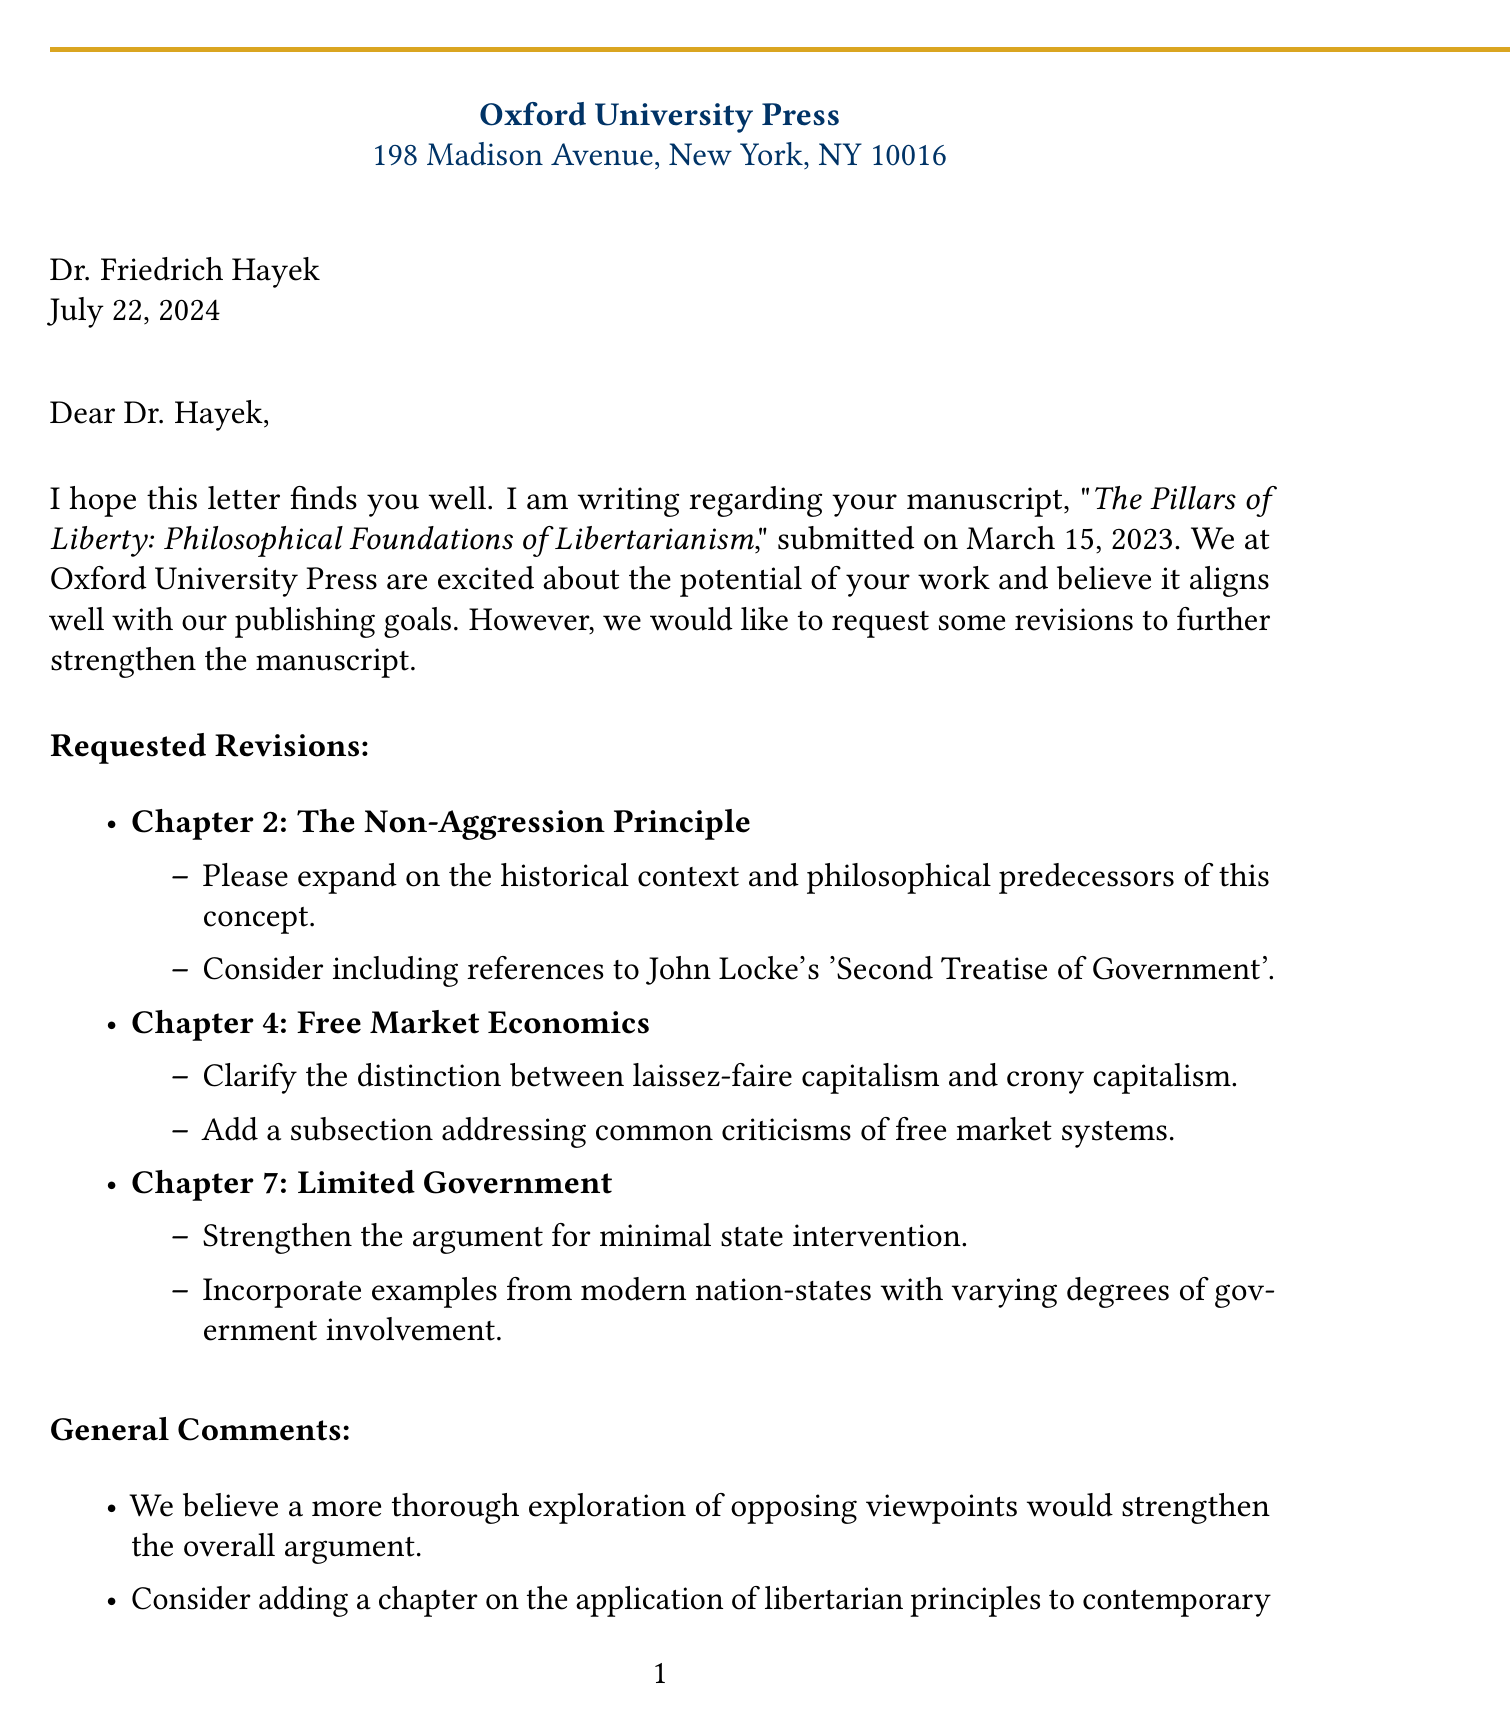what is the name of the publisher? The document specifies the publisher as "Oxford University Press."
Answer: Oxford University Press who is the editor of the manuscript? The letter addresses Dr. Emily Blackwell as the editor in charge.
Answer: Dr. Emily Blackwell when was the manuscript submitted? The submission date of the manuscript is explicitly listed in the document.
Answer: March 15, 2023 what is the title of the manuscript? The title of the manuscript is mentioned at the beginning of the letter.
Answer: The Pillars of Liberty: Philosophical Foundations of Libertarianism what is the deadline for the revised manuscript? The document states the date by which the revised manuscript should be submitted.
Answer: August 31, 2023 which chapter is suggested to include references to John Locke's work? The feedback refers to Chapter 2 regarding the inclusion of historical context.
Answer: Chapter 2: The Non-Aggression Principle what general comment suggests exploring opposing viewpoints? One of the general comments encourages this thorough exploration for stronger arguments.
Answer: A more thorough exploration of opposing viewpoints how many days is the conference scheduled for? The document presents the dates for the conference, which indicates the duration of the event.
Answer: Three days what is the location of the conference mentioned in the letter? The letter specifies the location of the conference as Cato Institute, Washington D.C.
Answer: Cato Institute, Washington D.C 